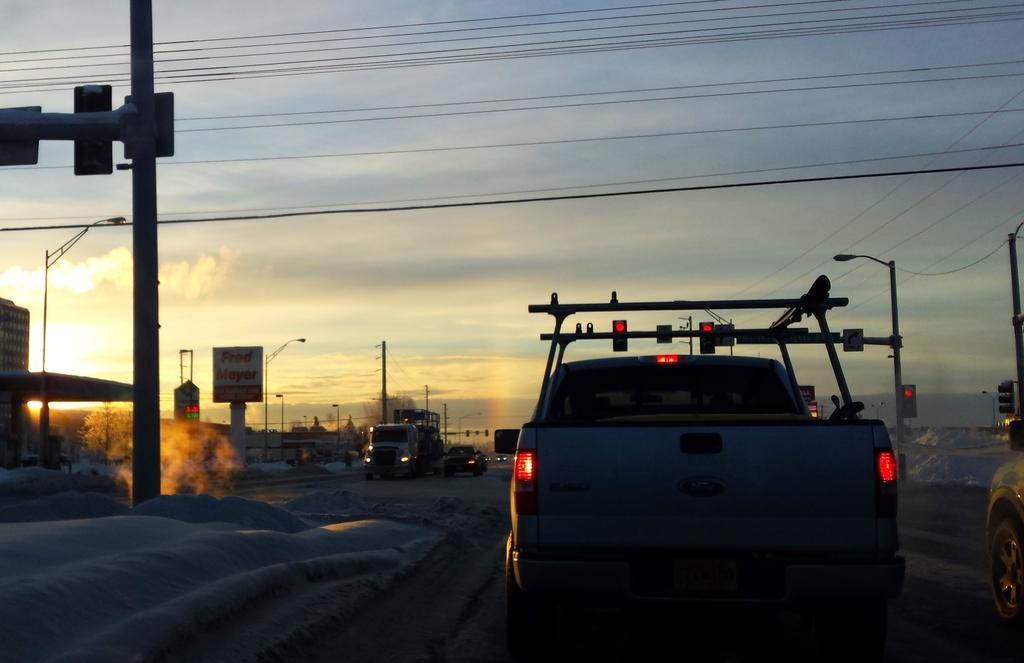What can be seen on the road in the image? There are vehicles on the road in the image. What helps regulate traffic in the image? Signal lights are present in the image. What type of structures are visible in the image? Boards and buildings are visible in the image. What is attached to poles in the image? Lights arets are attached to poles in the image. What type of vegetation is present in the image? Trees are present in the image. What is visible in the background of the image? The sky is visible in the background of the image. What type of shoe is your sister wearing in the image? There is no sister or shoe present in the image. What statement does the image make about the environment? The image does not make a statement about the environment; it simply depicts a scene with vehicles, signal lights, boards, lights, trees, buildings, and the sky. 